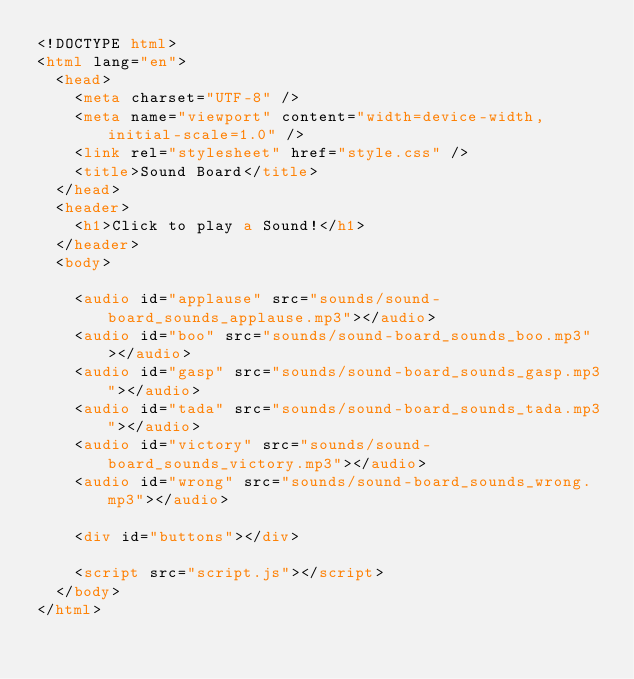<code> <loc_0><loc_0><loc_500><loc_500><_HTML_><!DOCTYPE html>
<html lang="en">
  <head>
    <meta charset="UTF-8" />
    <meta name="viewport" content="width=device-width, initial-scale=1.0" />
    <link rel="stylesheet" href="style.css" />
    <title>Sound Board</title>
  </head>
  <header>
    <h1>Click to play a Sound!</h1>
  </header>
  <body>
   
    <audio id="applause" src="sounds/sound-board_sounds_applause.mp3"></audio>
    <audio id="boo" src="sounds/sound-board_sounds_boo.mp3"></audio>
    <audio id="gasp" src="sounds/sound-board_sounds_gasp.mp3"></audio>
    <audio id="tada" src="sounds/sound-board_sounds_tada.mp3"></audio>
    <audio id="victory" src="sounds/sound-board_sounds_victory.mp3"></audio>
    <audio id="wrong" src="sounds/sound-board_sounds_wrong.mp3"></audio>

    <div id="buttons"></div>

    <script src="script.js"></script>
  </body>
</html></code> 